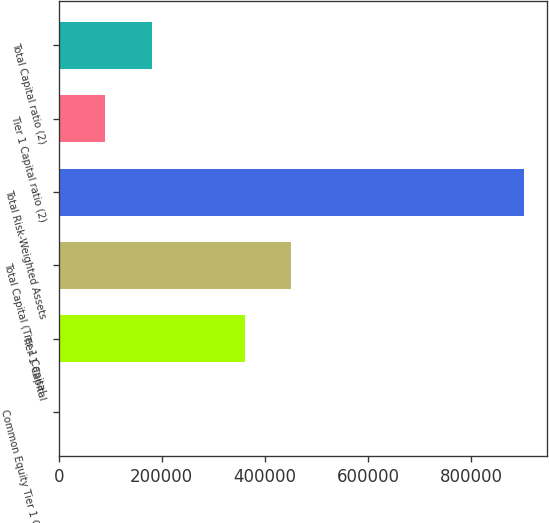Convert chart to OTSL. <chart><loc_0><loc_0><loc_500><loc_500><bar_chart><fcel>Common Equity Tier 1 Capital<fcel>Tier 1 Capital<fcel>Total Capital (Tier 1 Capital<fcel>Total Risk-Weighted Assets<fcel>Tier 1 Capital ratio (2)<fcel>Total Capital ratio (2)<nl><fcel>14.1<fcel>361196<fcel>451492<fcel>902969<fcel>90309.6<fcel>180605<nl></chart> 